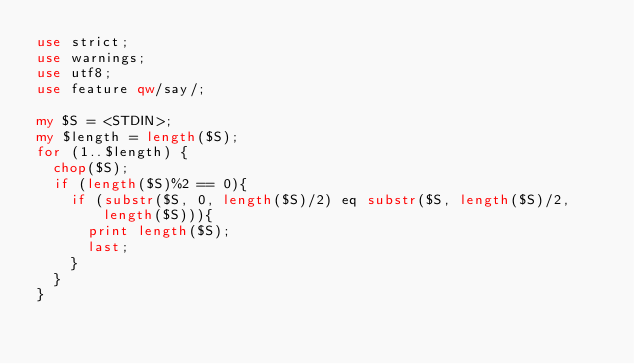Convert code to text. <code><loc_0><loc_0><loc_500><loc_500><_Perl_>use strict;
use warnings;
use utf8;
use feature qw/say/;

my $S = <STDIN>;
my $length = length($S);
for (1..$length) {
  chop($S);
  if (length($S)%2 == 0){
    if (substr($S, 0, length($S)/2) eq substr($S, length($S)/2, length($S))){
      print length($S);
      last;
    }
  }
}</code> 